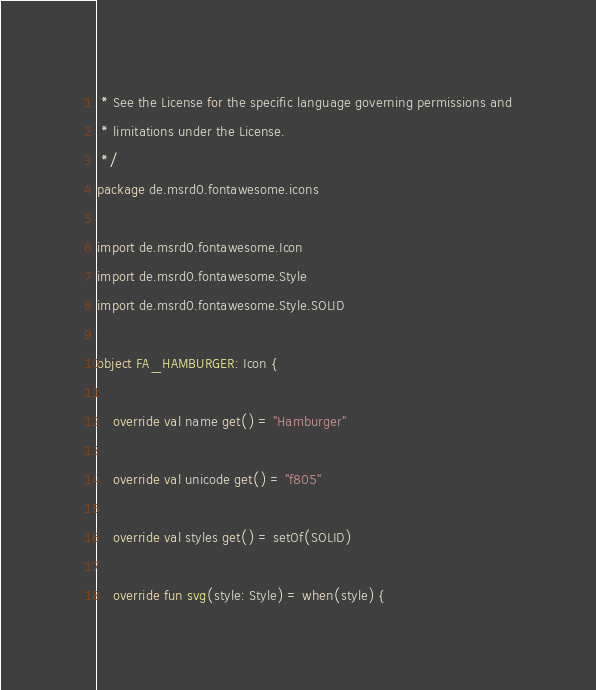Convert code to text. <code><loc_0><loc_0><loc_500><loc_500><_Kotlin_> * See the License for the specific language governing permissions and
 * limitations under the License.
 */
package de.msrd0.fontawesome.icons

import de.msrd0.fontawesome.Icon
import de.msrd0.fontawesome.Style
import de.msrd0.fontawesome.Style.SOLID

object FA_HAMBURGER: Icon {
	
	override val name get() = "Hamburger"
	
	override val unicode get() = "f805"
	
	override val styles get() = setOf(SOLID)
	
	override fun svg(style: Style) = when(style) {</code> 